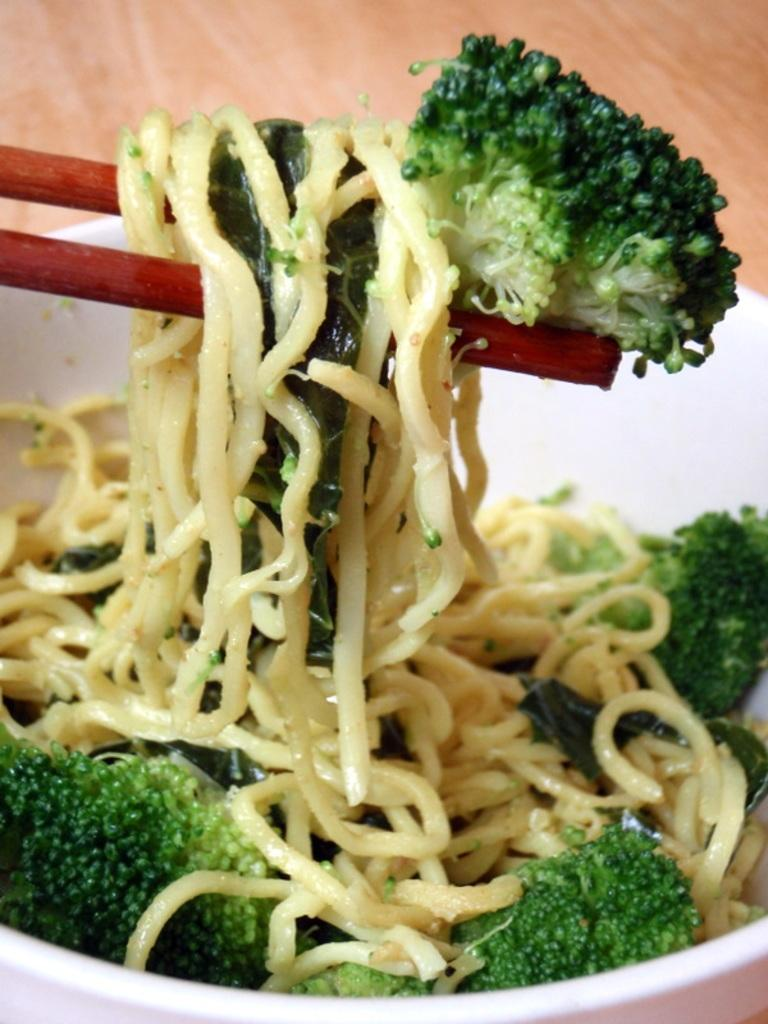What is in the bowl that is visible in the image? There is a bowl with noodles and broccoli in it. Where is the bowl located in the image? The bowl is placed on a table. What utensil is visible in the image? Chopsticks are visible in the image. What type of whip can be seen in the image? There is no whip present in the image; it features a bowl of noodles and broccoli with chopsticks on a table. 